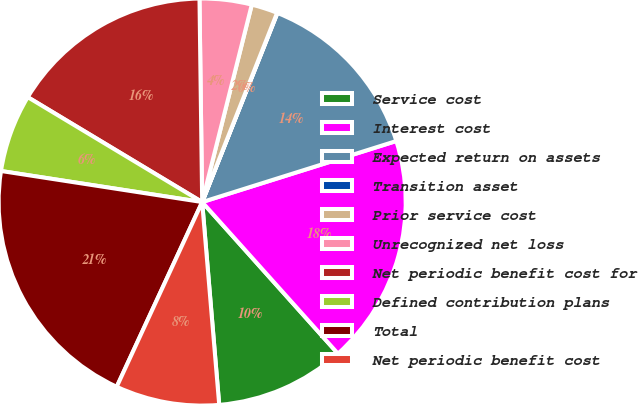<chart> <loc_0><loc_0><loc_500><loc_500><pie_chart><fcel>Service cost<fcel>Interest cost<fcel>Expected return on assets<fcel>Transition asset<fcel>Prior service cost<fcel>Unrecognized net loss<fcel>Net periodic benefit cost for<fcel>Defined contribution plans<fcel>Total<fcel>Net periodic benefit cost<nl><fcel>10.29%<fcel>18.22%<fcel>14.12%<fcel>0.03%<fcel>2.08%<fcel>4.13%<fcel>16.17%<fcel>6.18%<fcel>20.54%<fcel>8.23%<nl></chart> 